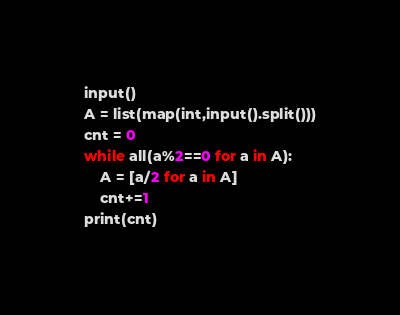Convert code to text. <code><loc_0><loc_0><loc_500><loc_500><_Python_>input()
A = list(map(int,input().split()))
cnt = 0
while all(a%2==0 for a in A):
    A = [a/2 for a in A]
    cnt+=1
print(cnt)</code> 